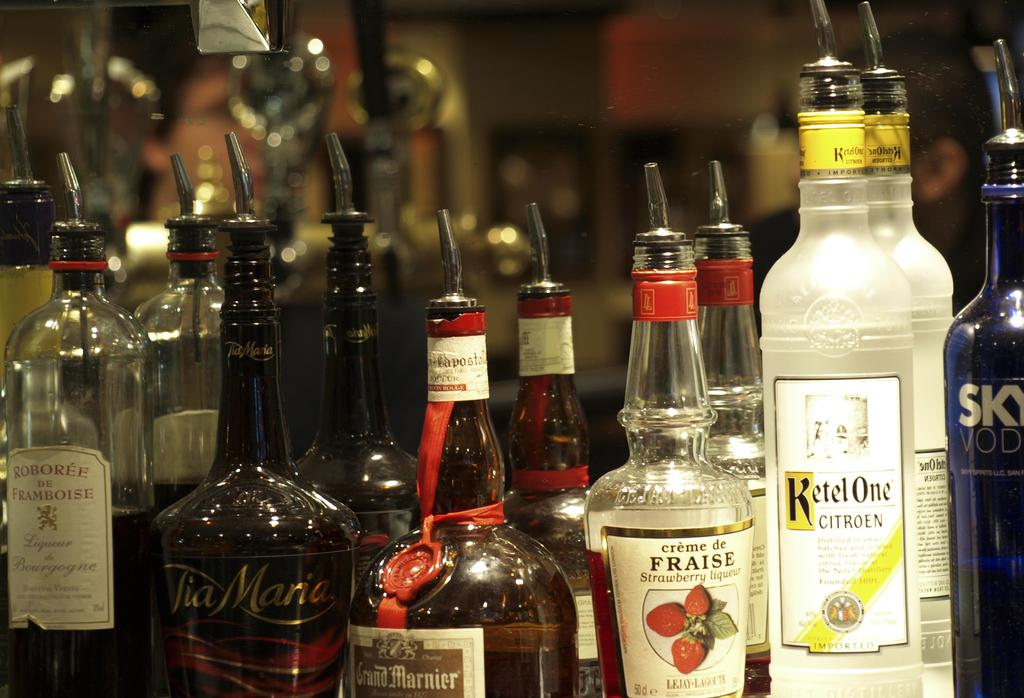What objects are located at the bottom of the image? There are bottles at the bottom of the image. Can you describe the color and position of the bottles in the image? There is a blue color bottle on the right side of the image and a white color bottle on the left side of the image. What year is depicted in the image? There is no year depicted in the image; it only shows bottles. 